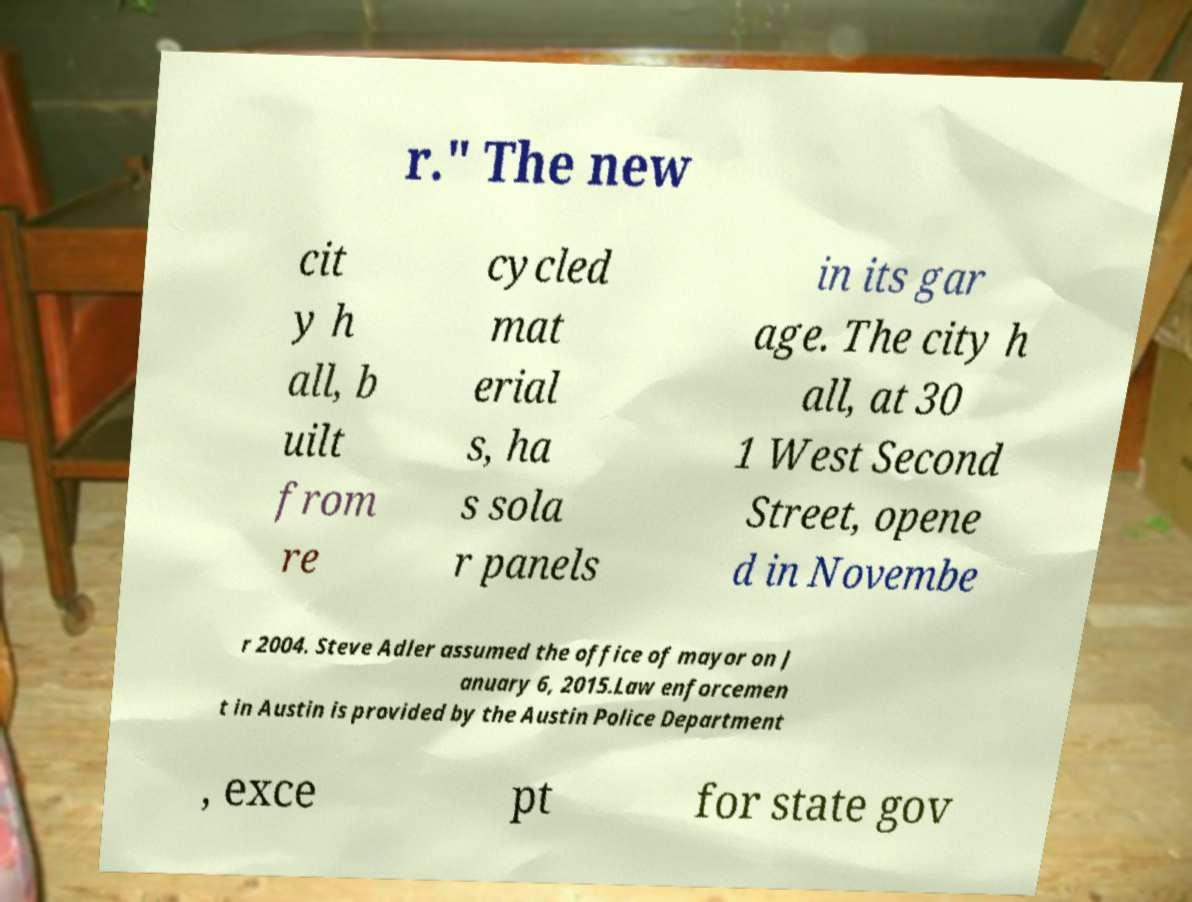Please identify and transcribe the text found in this image. r." The new cit y h all, b uilt from re cycled mat erial s, ha s sola r panels in its gar age. The city h all, at 30 1 West Second Street, opene d in Novembe r 2004. Steve Adler assumed the office of mayor on J anuary 6, 2015.Law enforcemen t in Austin is provided by the Austin Police Department , exce pt for state gov 